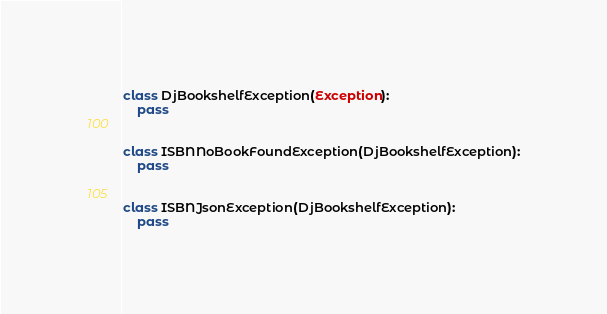<code> <loc_0><loc_0><loc_500><loc_500><_Python_>class DjBookshelfException(Exception):
    pass


class ISBNNoBookFoundException(DjBookshelfException):
    pass


class ISBNJsonException(DjBookshelfException):
    pass
</code> 